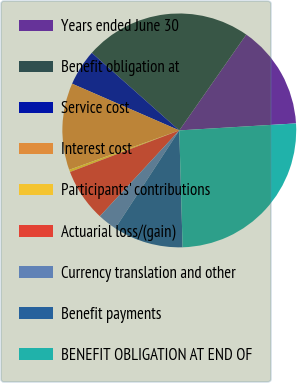Convert chart to OTSL. <chart><loc_0><loc_0><loc_500><loc_500><pie_chart><fcel>Years ended June 30<fcel>Benefit obligation at<fcel>Service cost<fcel>Interest cost<fcel>Participants' contributions<fcel>Actuarial loss/(gain)<fcel>Currency translation and other<fcel>Benefit payments<fcel>BENEFIT OBLIGATION AT END OF<nl><fcel>14.34%<fcel>23.16%<fcel>5.0%<fcel>12.01%<fcel>0.32%<fcel>7.33%<fcel>2.66%<fcel>9.67%<fcel>25.5%<nl></chart> 